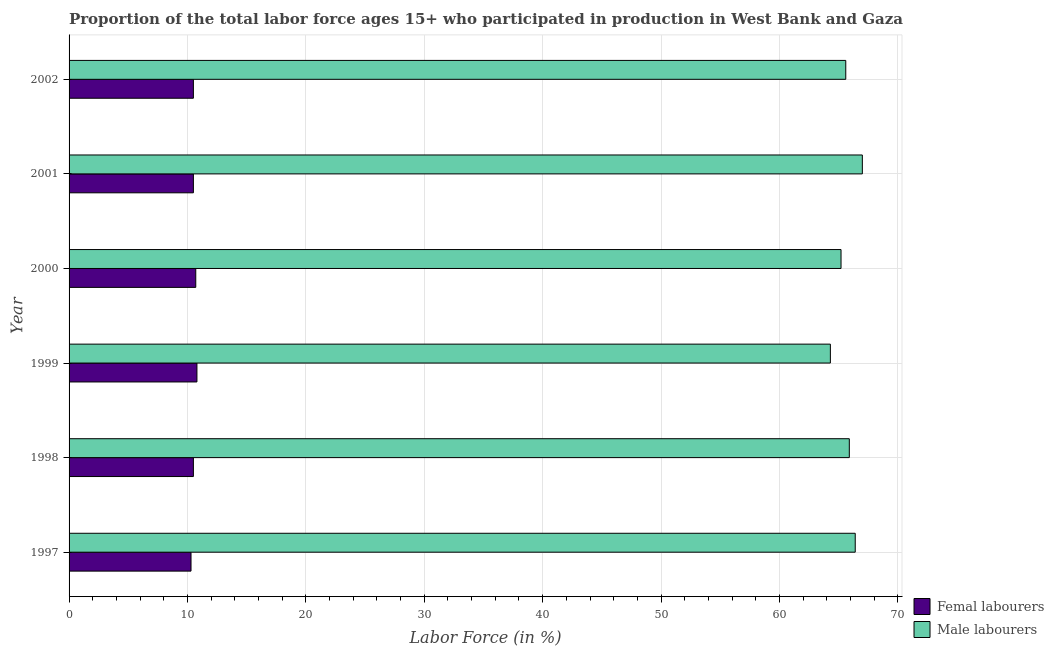How many groups of bars are there?
Give a very brief answer. 6. Are the number of bars per tick equal to the number of legend labels?
Keep it short and to the point. Yes. Are the number of bars on each tick of the Y-axis equal?
Provide a short and direct response. Yes. How many bars are there on the 4th tick from the top?
Your response must be concise. 2. In how many cases, is the number of bars for a given year not equal to the number of legend labels?
Offer a terse response. 0. What is the percentage of female labor force in 2000?
Your answer should be compact. 10.7. Across all years, what is the maximum percentage of female labor force?
Your answer should be very brief. 10.8. Across all years, what is the minimum percentage of male labour force?
Your response must be concise. 64.3. In which year was the percentage of male labour force maximum?
Provide a short and direct response. 2001. What is the total percentage of female labor force in the graph?
Give a very brief answer. 63.3. What is the difference between the percentage of female labor force in 2001 and the percentage of male labour force in 1997?
Provide a short and direct response. -55.9. What is the average percentage of female labor force per year?
Your answer should be compact. 10.55. In the year 2001, what is the difference between the percentage of male labour force and percentage of female labor force?
Ensure brevity in your answer.  56.5. What is the ratio of the percentage of female labor force in 1997 to that in 1999?
Provide a short and direct response. 0.95. Is the percentage of female labor force in 2001 less than that in 2002?
Keep it short and to the point. No. Is the difference between the percentage of female labor force in 1997 and 2002 greater than the difference between the percentage of male labour force in 1997 and 2002?
Your response must be concise. No. What is the difference between the highest and the lowest percentage of female labor force?
Your answer should be very brief. 0.5. Is the sum of the percentage of female labor force in 1999 and 2000 greater than the maximum percentage of male labour force across all years?
Keep it short and to the point. No. What does the 2nd bar from the top in 1998 represents?
Ensure brevity in your answer.  Femal labourers. What does the 1st bar from the bottom in 2001 represents?
Provide a succinct answer. Femal labourers. How many bars are there?
Give a very brief answer. 12. Are all the bars in the graph horizontal?
Offer a terse response. Yes. Are the values on the major ticks of X-axis written in scientific E-notation?
Provide a succinct answer. No. Does the graph contain any zero values?
Offer a very short reply. No. Where does the legend appear in the graph?
Your answer should be very brief. Bottom right. How are the legend labels stacked?
Your response must be concise. Vertical. What is the title of the graph?
Your answer should be compact. Proportion of the total labor force ages 15+ who participated in production in West Bank and Gaza. Does "Private credit bureau" appear as one of the legend labels in the graph?
Keep it short and to the point. No. What is the label or title of the X-axis?
Give a very brief answer. Labor Force (in %). What is the label or title of the Y-axis?
Your answer should be compact. Year. What is the Labor Force (in %) in Femal labourers in 1997?
Your answer should be compact. 10.3. What is the Labor Force (in %) in Male labourers in 1997?
Ensure brevity in your answer.  66.4. What is the Labor Force (in %) in Femal labourers in 1998?
Give a very brief answer. 10.5. What is the Labor Force (in %) in Male labourers in 1998?
Your answer should be very brief. 65.9. What is the Labor Force (in %) in Femal labourers in 1999?
Your response must be concise. 10.8. What is the Labor Force (in %) in Male labourers in 1999?
Ensure brevity in your answer.  64.3. What is the Labor Force (in %) in Femal labourers in 2000?
Provide a short and direct response. 10.7. What is the Labor Force (in %) in Male labourers in 2000?
Offer a terse response. 65.2. What is the Labor Force (in %) in Femal labourers in 2001?
Give a very brief answer. 10.5. What is the Labor Force (in %) in Male labourers in 2001?
Make the answer very short. 67. What is the Labor Force (in %) in Male labourers in 2002?
Offer a terse response. 65.6. Across all years, what is the maximum Labor Force (in %) in Femal labourers?
Your answer should be compact. 10.8. Across all years, what is the minimum Labor Force (in %) in Femal labourers?
Offer a very short reply. 10.3. Across all years, what is the minimum Labor Force (in %) in Male labourers?
Offer a terse response. 64.3. What is the total Labor Force (in %) in Femal labourers in the graph?
Offer a very short reply. 63.3. What is the total Labor Force (in %) of Male labourers in the graph?
Provide a short and direct response. 394.4. What is the difference between the Labor Force (in %) in Femal labourers in 1997 and that in 1998?
Provide a succinct answer. -0.2. What is the difference between the Labor Force (in %) of Male labourers in 1997 and that in 1998?
Provide a succinct answer. 0.5. What is the difference between the Labor Force (in %) of Femal labourers in 1997 and that in 1999?
Make the answer very short. -0.5. What is the difference between the Labor Force (in %) of Male labourers in 1997 and that in 1999?
Keep it short and to the point. 2.1. What is the difference between the Labor Force (in %) of Femal labourers in 1997 and that in 2000?
Your response must be concise. -0.4. What is the difference between the Labor Force (in %) in Male labourers in 1997 and that in 2000?
Your answer should be very brief. 1.2. What is the difference between the Labor Force (in %) in Femal labourers in 1997 and that in 2001?
Keep it short and to the point. -0.2. What is the difference between the Labor Force (in %) in Male labourers in 1998 and that in 2001?
Offer a very short reply. -1.1. What is the difference between the Labor Force (in %) in Male labourers in 1998 and that in 2002?
Your response must be concise. 0.3. What is the difference between the Labor Force (in %) in Male labourers in 1999 and that in 2001?
Offer a very short reply. -2.7. What is the difference between the Labor Force (in %) of Femal labourers in 1999 and that in 2002?
Offer a very short reply. 0.3. What is the difference between the Labor Force (in %) of Male labourers in 1999 and that in 2002?
Provide a succinct answer. -1.3. What is the difference between the Labor Force (in %) of Femal labourers in 2000 and that in 2001?
Offer a very short reply. 0.2. What is the difference between the Labor Force (in %) of Male labourers in 2000 and that in 2002?
Ensure brevity in your answer.  -0.4. What is the difference between the Labor Force (in %) of Male labourers in 2001 and that in 2002?
Give a very brief answer. 1.4. What is the difference between the Labor Force (in %) of Femal labourers in 1997 and the Labor Force (in %) of Male labourers in 1998?
Your answer should be very brief. -55.6. What is the difference between the Labor Force (in %) in Femal labourers in 1997 and the Labor Force (in %) in Male labourers in 1999?
Your answer should be compact. -54. What is the difference between the Labor Force (in %) in Femal labourers in 1997 and the Labor Force (in %) in Male labourers in 2000?
Your answer should be very brief. -54.9. What is the difference between the Labor Force (in %) in Femal labourers in 1997 and the Labor Force (in %) in Male labourers in 2001?
Make the answer very short. -56.7. What is the difference between the Labor Force (in %) of Femal labourers in 1997 and the Labor Force (in %) of Male labourers in 2002?
Offer a very short reply. -55.3. What is the difference between the Labor Force (in %) of Femal labourers in 1998 and the Labor Force (in %) of Male labourers in 1999?
Offer a very short reply. -53.8. What is the difference between the Labor Force (in %) in Femal labourers in 1998 and the Labor Force (in %) in Male labourers in 2000?
Keep it short and to the point. -54.7. What is the difference between the Labor Force (in %) of Femal labourers in 1998 and the Labor Force (in %) of Male labourers in 2001?
Offer a very short reply. -56.5. What is the difference between the Labor Force (in %) of Femal labourers in 1998 and the Labor Force (in %) of Male labourers in 2002?
Provide a succinct answer. -55.1. What is the difference between the Labor Force (in %) in Femal labourers in 1999 and the Labor Force (in %) in Male labourers in 2000?
Your answer should be very brief. -54.4. What is the difference between the Labor Force (in %) in Femal labourers in 1999 and the Labor Force (in %) in Male labourers in 2001?
Offer a very short reply. -56.2. What is the difference between the Labor Force (in %) of Femal labourers in 1999 and the Labor Force (in %) of Male labourers in 2002?
Make the answer very short. -54.8. What is the difference between the Labor Force (in %) in Femal labourers in 2000 and the Labor Force (in %) in Male labourers in 2001?
Keep it short and to the point. -56.3. What is the difference between the Labor Force (in %) of Femal labourers in 2000 and the Labor Force (in %) of Male labourers in 2002?
Offer a very short reply. -54.9. What is the difference between the Labor Force (in %) in Femal labourers in 2001 and the Labor Force (in %) in Male labourers in 2002?
Provide a succinct answer. -55.1. What is the average Labor Force (in %) in Femal labourers per year?
Your answer should be very brief. 10.55. What is the average Labor Force (in %) in Male labourers per year?
Offer a very short reply. 65.73. In the year 1997, what is the difference between the Labor Force (in %) of Femal labourers and Labor Force (in %) of Male labourers?
Give a very brief answer. -56.1. In the year 1998, what is the difference between the Labor Force (in %) in Femal labourers and Labor Force (in %) in Male labourers?
Offer a very short reply. -55.4. In the year 1999, what is the difference between the Labor Force (in %) in Femal labourers and Labor Force (in %) in Male labourers?
Offer a very short reply. -53.5. In the year 2000, what is the difference between the Labor Force (in %) in Femal labourers and Labor Force (in %) in Male labourers?
Provide a succinct answer. -54.5. In the year 2001, what is the difference between the Labor Force (in %) of Femal labourers and Labor Force (in %) of Male labourers?
Your answer should be very brief. -56.5. In the year 2002, what is the difference between the Labor Force (in %) of Femal labourers and Labor Force (in %) of Male labourers?
Provide a short and direct response. -55.1. What is the ratio of the Labor Force (in %) of Femal labourers in 1997 to that in 1998?
Make the answer very short. 0.98. What is the ratio of the Labor Force (in %) in Male labourers in 1997 to that in 1998?
Provide a short and direct response. 1.01. What is the ratio of the Labor Force (in %) in Femal labourers in 1997 to that in 1999?
Your answer should be compact. 0.95. What is the ratio of the Labor Force (in %) in Male labourers in 1997 to that in 1999?
Ensure brevity in your answer.  1.03. What is the ratio of the Labor Force (in %) in Femal labourers in 1997 to that in 2000?
Your answer should be very brief. 0.96. What is the ratio of the Labor Force (in %) in Male labourers in 1997 to that in 2000?
Your answer should be very brief. 1.02. What is the ratio of the Labor Force (in %) of Femal labourers in 1997 to that in 2001?
Give a very brief answer. 0.98. What is the ratio of the Labor Force (in %) in Male labourers in 1997 to that in 2001?
Your answer should be compact. 0.99. What is the ratio of the Labor Force (in %) of Male labourers in 1997 to that in 2002?
Ensure brevity in your answer.  1.01. What is the ratio of the Labor Force (in %) in Femal labourers in 1998 to that in 1999?
Ensure brevity in your answer.  0.97. What is the ratio of the Labor Force (in %) of Male labourers in 1998 to that in 1999?
Offer a terse response. 1.02. What is the ratio of the Labor Force (in %) in Femal labourers in 1998 to that in 2000?
Provide a succinct answer. 0.98. What is the ratio of the Labor Force (in %) in Male labourers in 1998 to that in 2000?
Provide a short and direct response. 1.01. What is the ratio of the Labor Force (in %) in Femal labourers in 1998 to that in 2001?
Offer a terse response. 1. What is the ratio of the Labor Force (in %) in Male labourers in 1998 to that in 2001?
Your answer should be very brief. 0.98. What is the ratio of the Labor Force (in %) of Femal labourers in 1999 to that in 2000?
Offer a terse response. 1.01. What is the ratio of the Labor Force (in %) in Male labourers in 1999 to that in 2000?
Ensure brevity in your answer.  0.99. What is the ratio of the Labor Force (in %) in Femal labourers in 1999 to that in 2001?
Provide a short and direct response. 1.03. What is the ratio of the Labor Force (in %) in Male labourers in 1999 to that in 2001?
Your answer should be very brief. 0.96. What is the ratio of the Labor Force (in %) in Femal labourers in 1999 to that in 2002?
Make the answer very short. 1.03. What is the ratio of the Labor Force (in %) of Male labourers in 1999 to that in 2002?
Offer a terse response. 0.98. What is the ratio of the Labor Force (in %) of Male labourers in 2000 to that in 2001?
Your answer should be very brief. 0.97. What is the ratio of the Labor Force (in %) in Male labourers in 2001 to that in 2002?
Offer a very short reply. 1.02. What is the difference between the highest and the second highest Labor Force (in %) of Male labourers?
Provide a short and direct response. 0.6. What is the difference between the highest and the lowest Labor Force (in %) of Femal labourers?
Make the answer very short. 0.5. What is the difference between the highest and the lowest Labor Force (in %) in Male labourers?
Your answer should be compact. 2.7. 